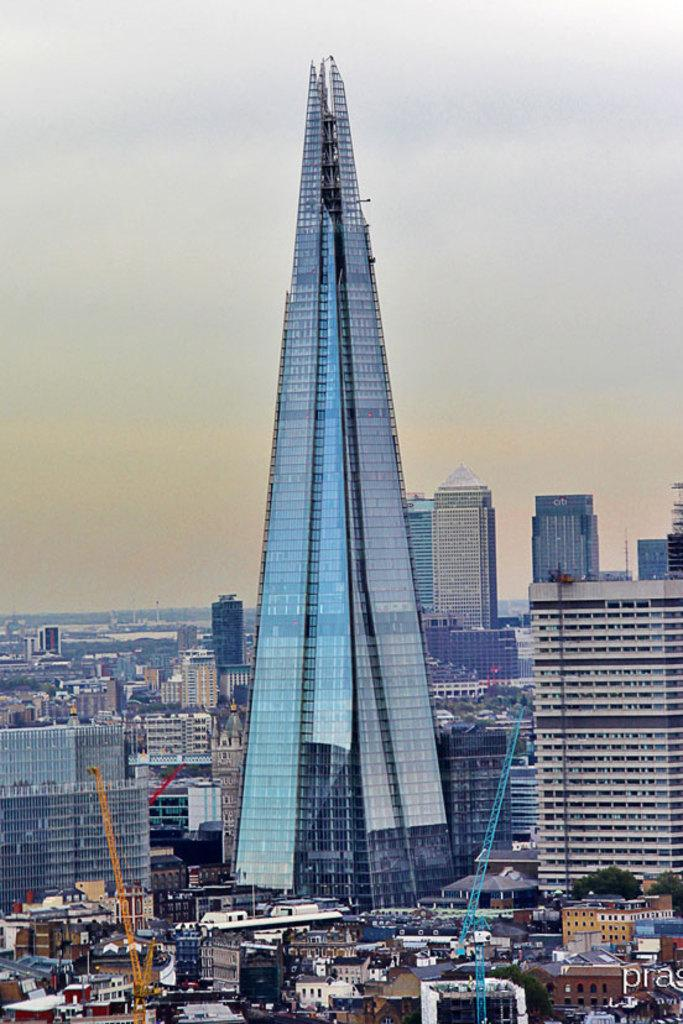What type of location is shown in the image? The image depicts a city. What types of structures can be seen in the city? There are houses, buildings, and tower buildings with glass in the city. How many buildings are visible in the background? There are many buildings visible in the background. What can be seen in the sky in the image? The sky is visible in the image. Where can the bee's friend be found in the image? There are no bees or their friends present in the image, as it depicts a city with various buildings and structures. 